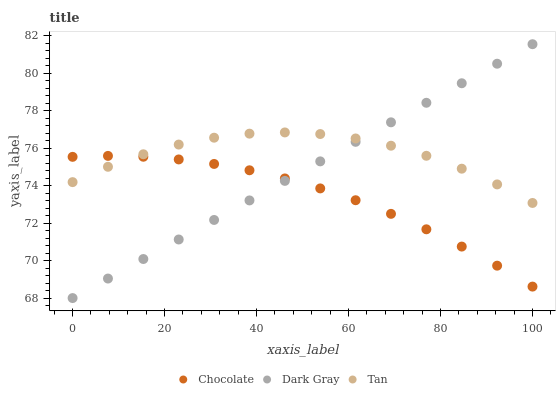Does Chocolate have the minimum area under the curve?
Answer yes or no. Yes. Does Tan have the maximum area under the curve?
Answer yes or no. Yes. Does Tan have the minimum area under the curve?
Answer yes or no. No. Does Chocolate have the maximum area under the curve?
Answer yes or no. No. Is Dark Gray the smoothest?
Answer yes or no. Yes. Is Tan the roughest?
Answer yes or no. Yes. Is Chocolate the smoothest?
Answer yes or no. No. Is Chocolate the roughest?
Answer yes or no. No. Does Dark Gray have the lowest value?
Answer yes or no. Yes. Does Chocolate have the lowest value?
Answer yes or no. No. Does Dark Gray have the highest value?
Answer yes or no. Yes. Does Tan have the highest value?
Answer yes or no. No. Does Dark Gray intersect Tan?
Answer yes or no. Yes. Is Dark Gray less than Tan?
Answer yes or no. No. Is Dark Gray greater than Tan?
Answer yes or no. No. 